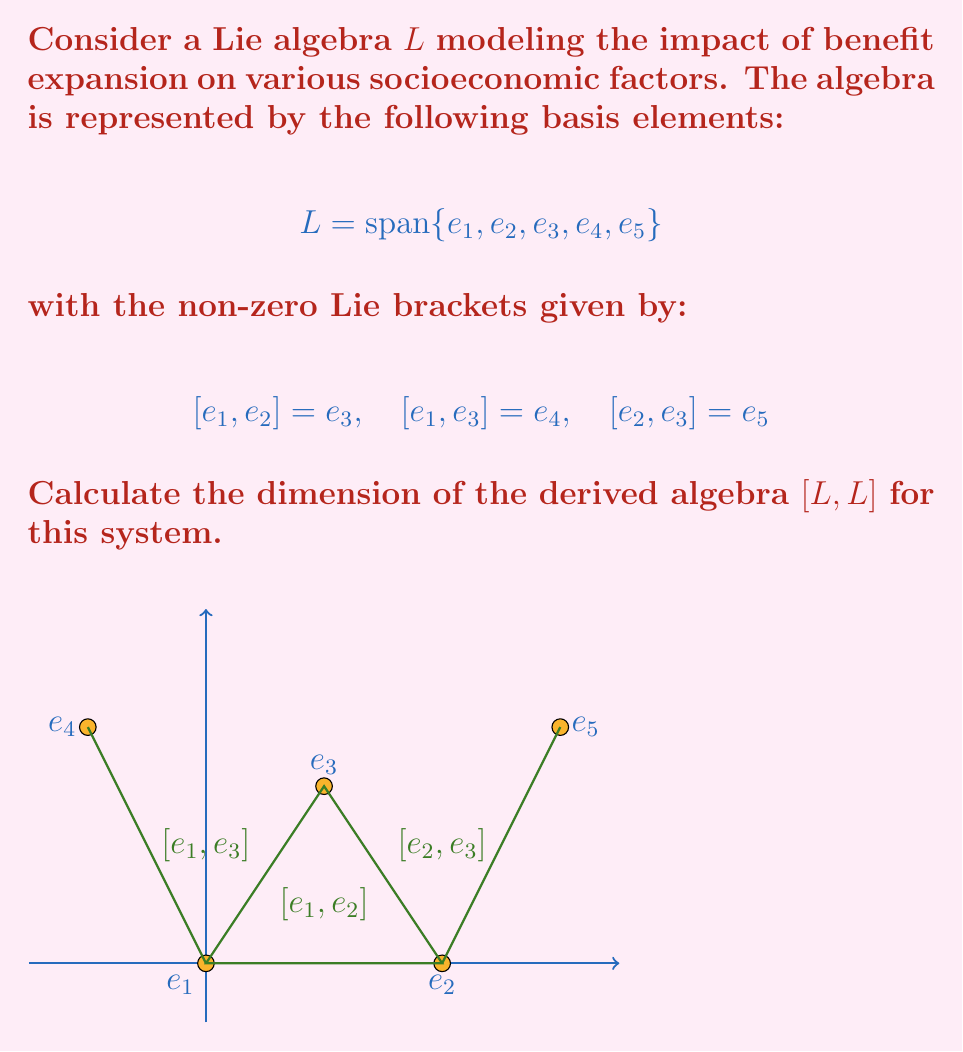Solve this math problem. To find the dimension of the derived algebra $[L,L]$, we need to follow these steps:

1) First, recall that the derived algebra $[L,L]$ is the subspace of $L$ generated by all Lie brackets $[x,y]$ where $x,y \in L$.

2) From the given Lie brackets, we can see that:
   $$ [L,L] = \text{span}\{[e_1,e_2], [e_1,e_3], [e_2,e_3]\} $$

3) Substituting the given relations:
   $$ [L,L] = \text{span}\{e_3, e_4, e_5\} $$

4) To find the dimension of $[L,L]$, we need to determine if these spanning elements are linearly independent.

5) Since $e_3$, $e_4$, and $e_5$ are distinct basis elements of the original algebra $L$, they are linearly independent.

6) Therefore, the set $\{e_3, e_4, e_5\}$ forms a basis for $[L,L]$.

7) The dimension of a vector space is equal to the number of elements in its basis.

8) Thus, the dimension of $[L,L]$ is 3.

This result indicates that the benefit expansion model generates three independent factors in its derived algebra, potentially representing secondary effects or interactions within the socioeconomic system.
Answer: 3 